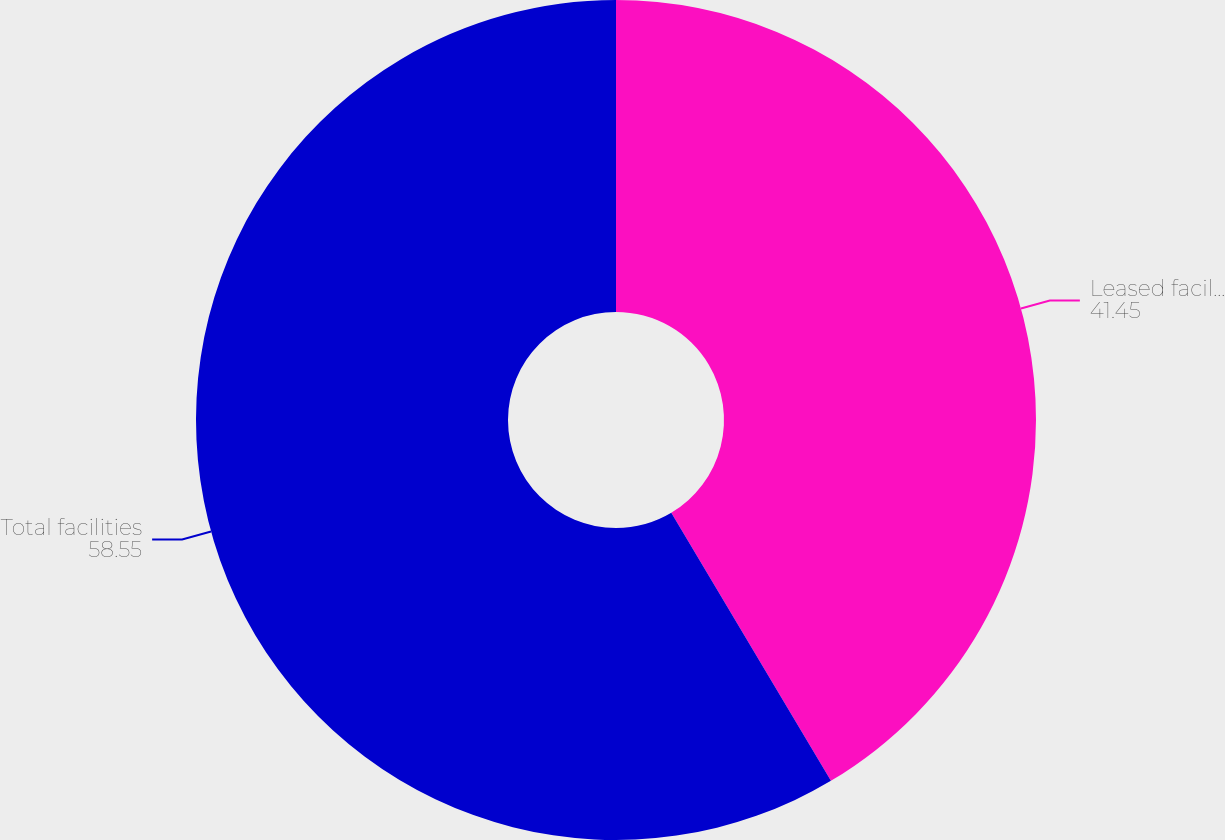Convert chart. <chart><loc_0><loc_0><loc_500><loc_500><pie_chart><fcel>Leased facilities<fcel>Total facilities<nl><fcel>41.45%<fcel>58.55%<nl></chart> 